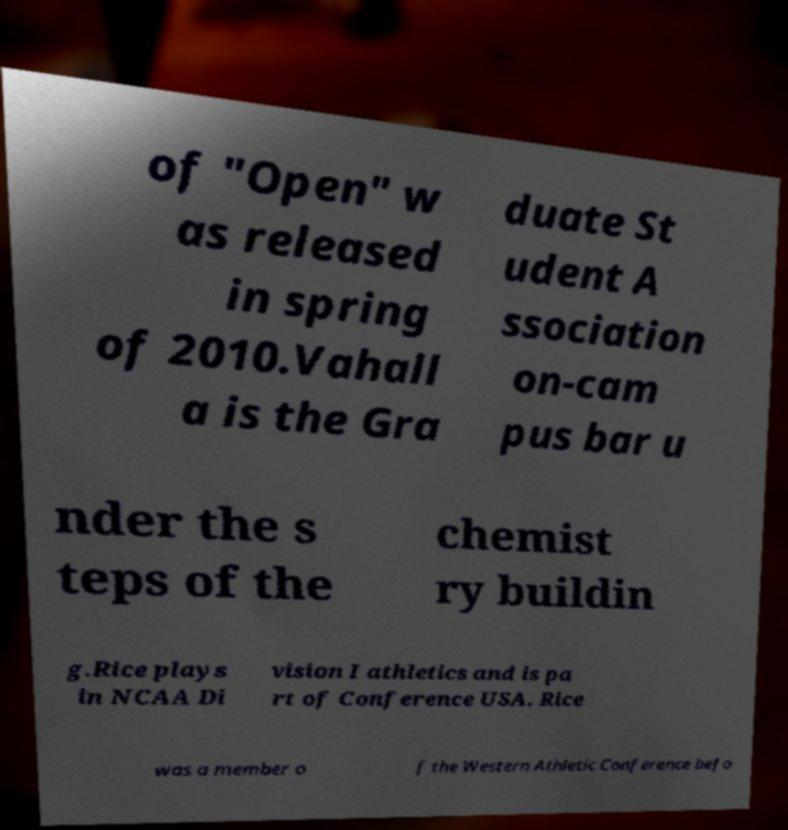Could you extract and type out the text from this image? of "Open" w as released in spring of 2010.Vahall a is the Gra duate St udent A ssociation on-cam pus bar u nder the s teps of the chemist ry buildin g.Rice plays in NCAA Di vision I athletics and is pa rt of Conference USA. Rice was a member o f the Western Athletic Conference befo 